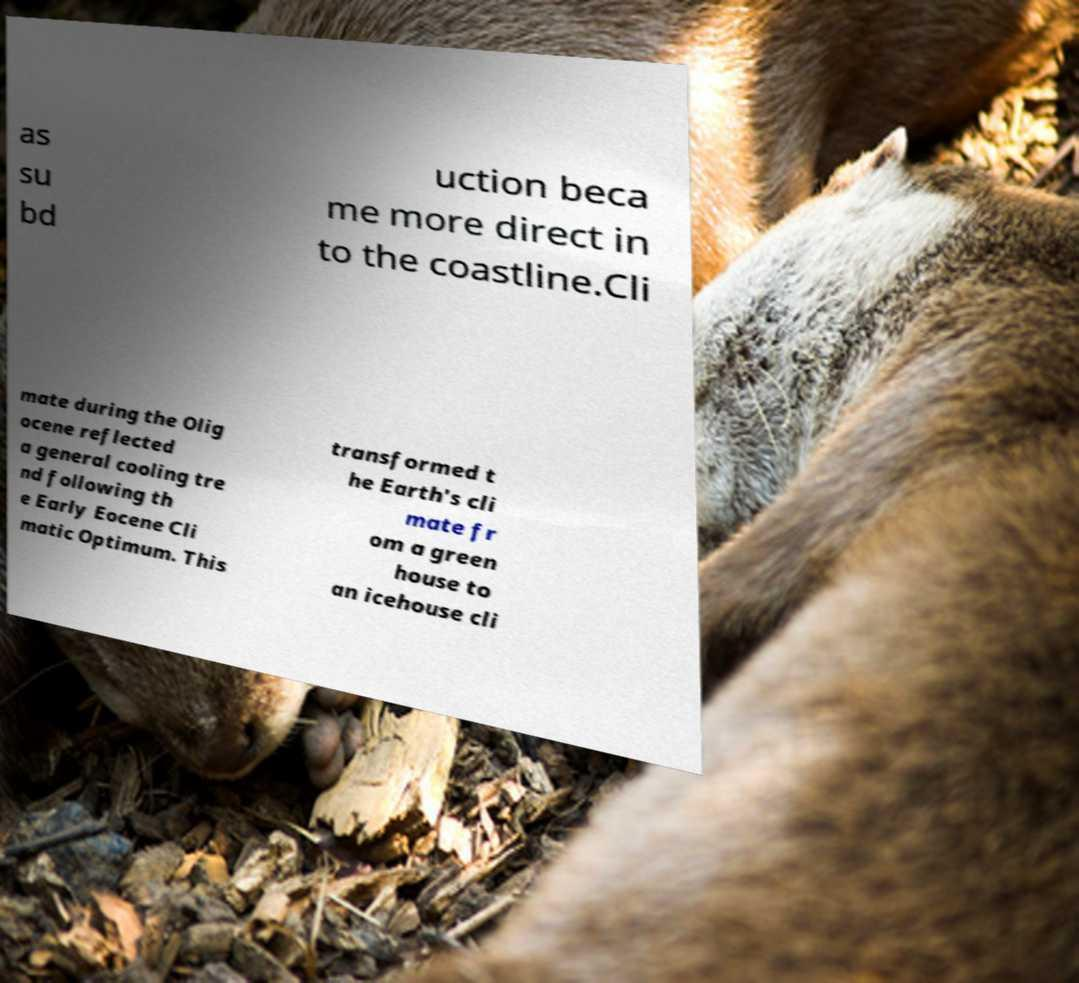Can you accurately transcribe the text from the provided image for me? as su bd uction beca me more direct in to the coastline.Cli mate during the Olig ocene reflected a general cooling tre nd following th e Early Eocene Cli matic Optimum. This transformed t he Earth's cli mate fr om a green house to an icehouse cli 